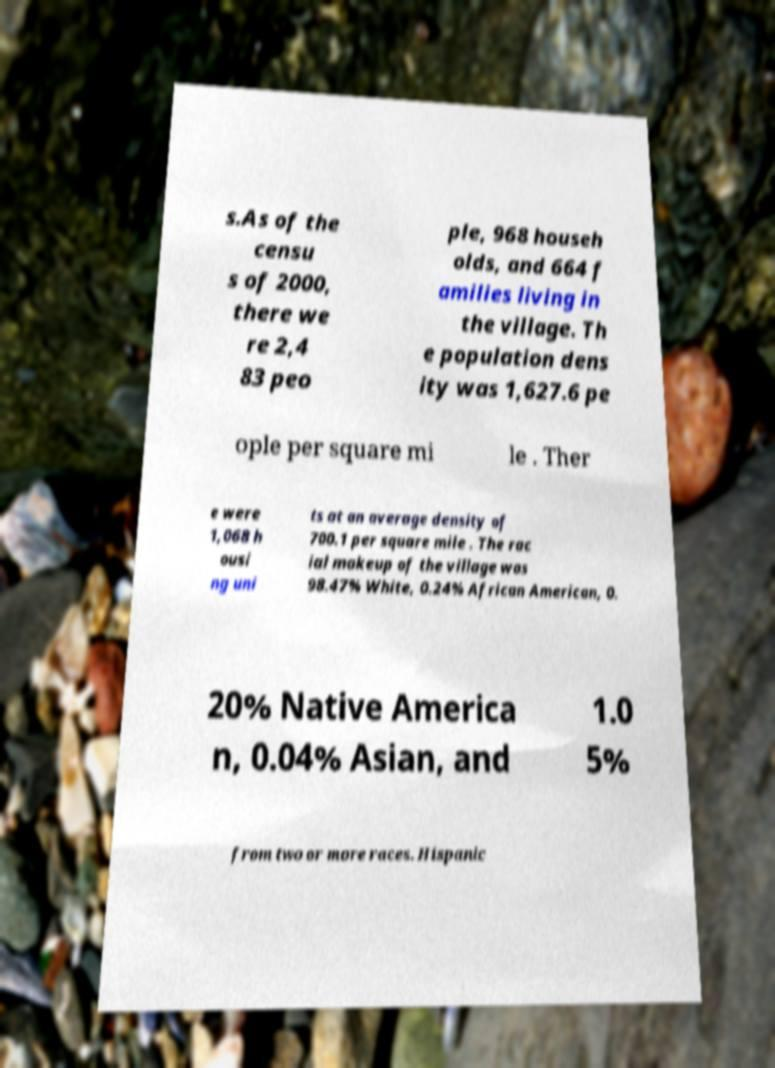Please read and relay the text visible in this image. What does it say? s.As of the censu s of 2000, there we re 2,4 83 peo ple, 968 househ olds, and 664 f amilies living in the village. Th e population dens ity was 1,627.6 pe ople per square mi le . Ther e were 1,068 h ousi ng uni ts at an average density of 700.1 per square mile . The rac ial makeup of the village was 98.47% White, 0.24% African American, 0. 20% Native America n, 0.04% Asian, and 1.0 5% from two or more races. Hispanic 